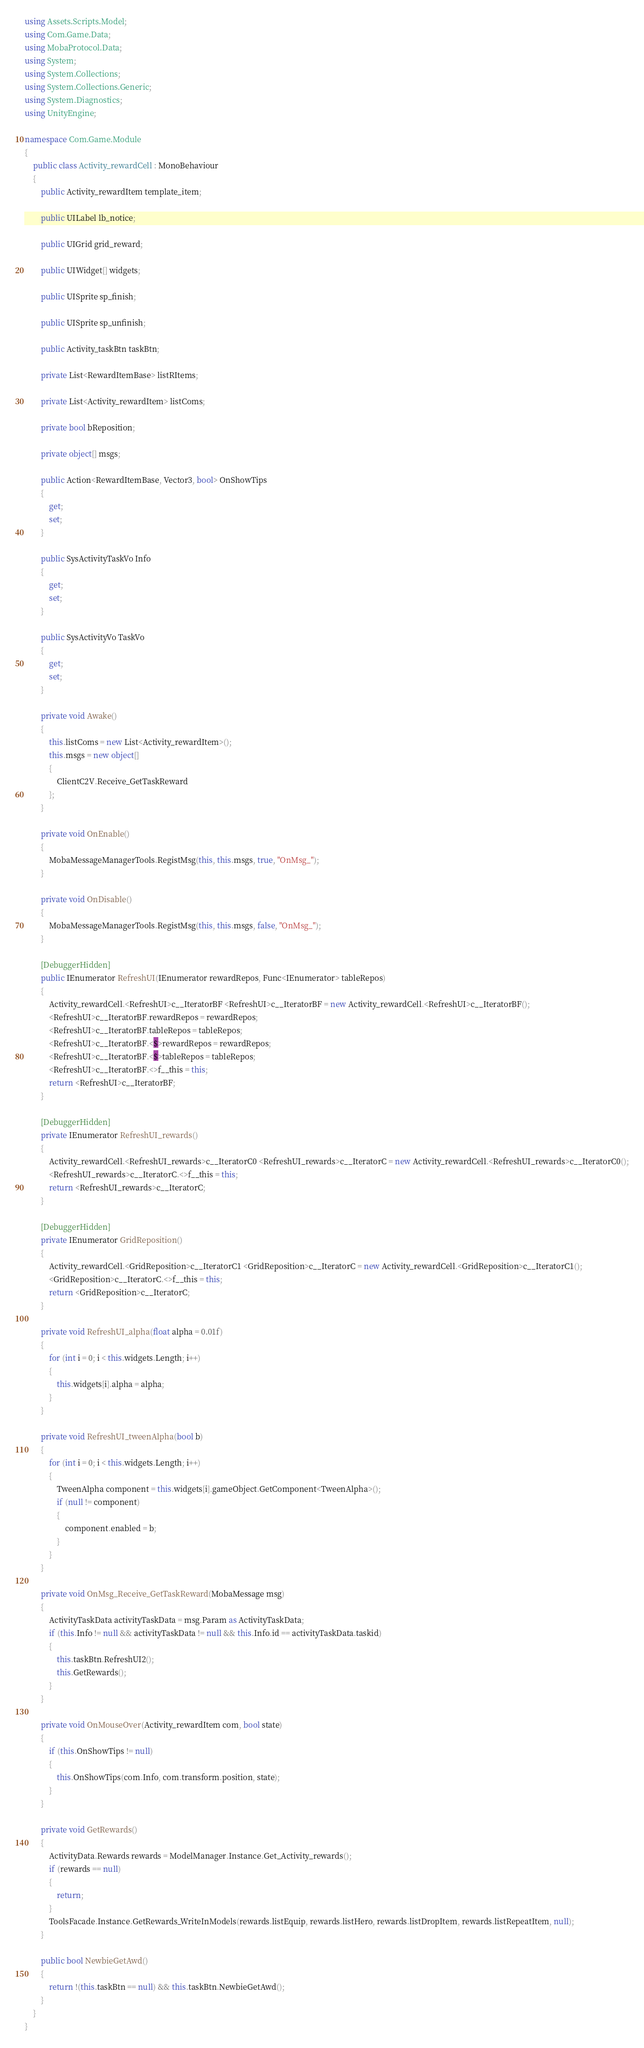Convert code to text. <code><loc_0><loc_0><loc_500><loc_500><_C#_>using Assets.Scripts.Model;
using Com.Game.Data;
using MobaProtocol.Data;
using System;
using System.Collections;
using System.Collections.Generic;
using System.Diagnostics;
using UnityEngine;

namespace Com.Game.Module
{
	public class Activity_rewardCell : MonoBehaviour
	{
		public Activity_rewardItem template_item;

		public UILabel lb_notice;

		public UIGrid grid_reward;

		public UIWidget[] widgets;

		public UISprite sp_finish;

		public UISprite sp_unfinish;

		public Activity_taskBtn taskBtn;

		private List<RewardItemBase> listRItems;

		private List<Activity_rewardItem> listComs;

		private bool bReposition;

		private object[] msgs;

		public Action<RewardItemBase, Vector3, bool> OnShowTips
		{
			get;
			set;
		}

		public SysActivityTaskVo Info
		{
			get;
			set;
		}

		public SysActivityVo TaskVo
		{
			get;
			set;
		}

		private void Awake()
		{
			this.listComs = new List<Activity_rewardItem>();
			this.msgs = new object[]
			{
				ClientC2V.Receive_GetTaskReward
			};
		}

		private void OnEnable()
		{
			MobaMessageManagerTools.RegistMsg(this, this.msgs, true, "OnMsg_");
		}

		private void OnDisable()
		{
			MobaMessageManagerTools.RegistMsg(this, this.msgs, false, "OnMsg_");
		}

		[DebuggerHidden]
		public IEnumerator RefreshUI(IEnumerator rewardRepos, Func<IEnumerator> tableRepos)
		{
			Activity_rewardCell.<RefreshUI>c__IteratorBF <RefreshUI>c__IteratorBF = new Activity_rewardCell.<RefreshUI>c__IteratorBF();
			<RefreshUI>c__IteratorBF.rewardRepos = rewardRepos;
			<RefreshUI>c__IteratorBF.tableRepos = tableRepos;
			<RefreshUI>c__IteratorBF.<$>rewardRepos = rewardRepos;
			<RefreshUI>c__IteratorBF.<$>tableRepos = tableRepos;
			<RefreshUI>c__IteratorBF.<>f__this = this;
			return <RefreshUI>c__IteratorBF;
		}

		[DebuggerHidden]
		private IEnumerator RefreshUI_rewards()
		{
			Activity_rewardCell.<RefreshUI_rewards>c__IteratorC0 <RefreshUI_rewards>c__IteratorC = new Activity_rewardCell.<RefreshUI_rewards>c__IteratorC0();
			<RefreshUI_rewards>c__IteratorC.<>f__this = this;
			return <RefreshUI_rewards>c__IteratorC;
		}

		[DebuggerHidden]
		private IEnumerator GridReposition()
		{
			Activity_rewardCell.<GridReposition>c__IteratorC1 <GridReposition>c__IteratorC = new Activity_rewardCell.<GridReposition>c__IteratorC1();
			<GridReposition>c__IteratorC.<>f__this = this;
			return <GridReposition>c__IteratorC;
		}

		private void RefreshUI_alpha(float alpha = 0.01f)
		{
			for (int i = 0; i < this.widgets.Length; i++)
			{
				this.widgets[i].alpha = alpha;
			}
		}

		private void RefreshUI_tweenAlpha(bool b)
		{
			for (int i = 0; i < this.widgets.Length; i++)
			{
				TweenAlpha component = this.widgets[i].gameObject.GetComponent<TweenAlpha>();
				if (null != component)
				{
					component.enabled = b;
				}
			}
		}

		private void OnMsg_Receive_GetTaskReward(MobaMessage msg)
		{
			ActivityTaskData activityTaskData = msg.Param as ActivityTaskData;
			if (this.Info != null && activityTaskData != null && this.Info.id == activityTaskData.taskid)
			{
				this.taskBtn.RefreshUI2();
				this.GetRewards();
			}
		}

		private void OnMouseOver(Activity_rewardItem com, bool state)
		{
			if (this.OnShowTips != null)
			{
				this.OnShowTips(com.Info, com.transform.position, state);
			}
		}

		private void GetRewards()
		{
			ActivityData.Rewards rewards = ModelManager.Instance.Get_Activity_rewards();
			if (rewards == null)
			{
				return;
			}
			ToolsFacade.Instance.GetRewards_WriteInModels(rewards.listEquip, rewards.listHero, rewards.listDropItem, rewards.listRepeatItem, null);
		}

		public bool NewbieGetAwd()
		{
			return !(this.taskBtn == null) && this.taskBtn.NewbieGetAwd();
		}
	}
}
</code> 